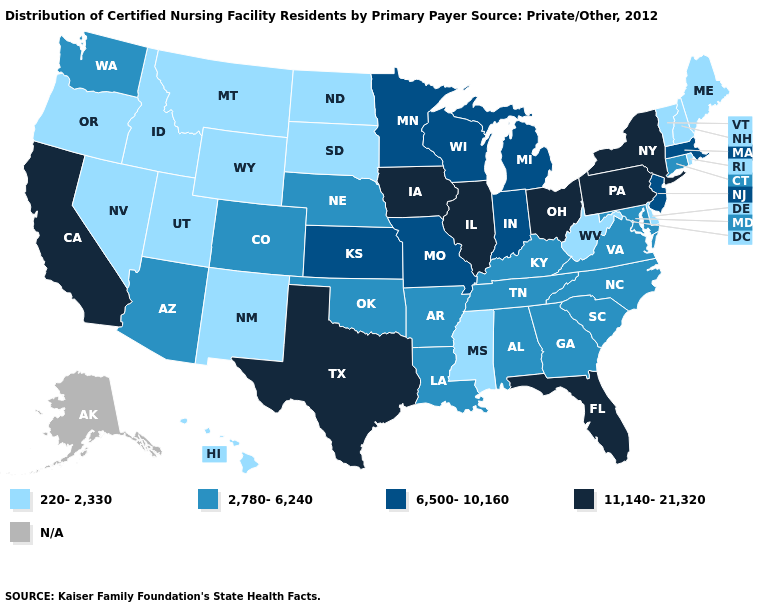What is the value of Montana?
Concise answer only. 220-2,330. Name the states that have a value in the range 6,500-10,160?
Concise answer only. Indiana, Kansas, Massachusetts, Michigan, Minnesota, Missouri, New Jersey, Wisconsin. Name the states that have a value in the range 2,780-6,240?
Short answer required. Alabama, Arizona, Arkansas, Colorado, Connecticut, Georgia, Kentucky, Louisiana, Maryland, Nebraska, North Carolina, Oklahoma, South Carolina, Tennessee, Virginia, Washington. Name the states that have a value in the range 2,780-6,240?
Be succinct. Alabama, Arizona, Arkansas, Colorado, Connecticut, Georgia, Kentucky, Louisiana, Maryland, Nebraska, North Carolina, Oklahoma, South Carolina, Tennessee, Virginia, Washington. What is the value of Indiana?
Quick response, please. 6,500-10,160. Name the states that have a value in the range 11,140-21,320?
Be succinct. California, Florida, Illinois, Iowa, New York, Ohio, Pennsylvania, Texas. Name the states that have a value in the range N/A?
Give a very brief answer. Alaska. Name the states that have a value in the range N/A?
Be succinct. Alaska. Among the states that border Kansas , which have the lowest value?
Keep it brief. Colorado, Nebraska, Oklahoma. What is the highest value in states that border West Virginia?
Give a very brief answer. 11,140-21,320. Among the states that border Nebraska , does Missouri have the highest value?
Give a very brief answer. No. Which states have the highest value in the USA?
Give a very brief answer. California, Florida, Illinois, Iowa, New York, Ohio, Pennsylvania, Texas. What is the value of Wisconsin?
Quick response, please. 6,500-10,160. Does the map have missing data?
Write a very short answer. Yes. 